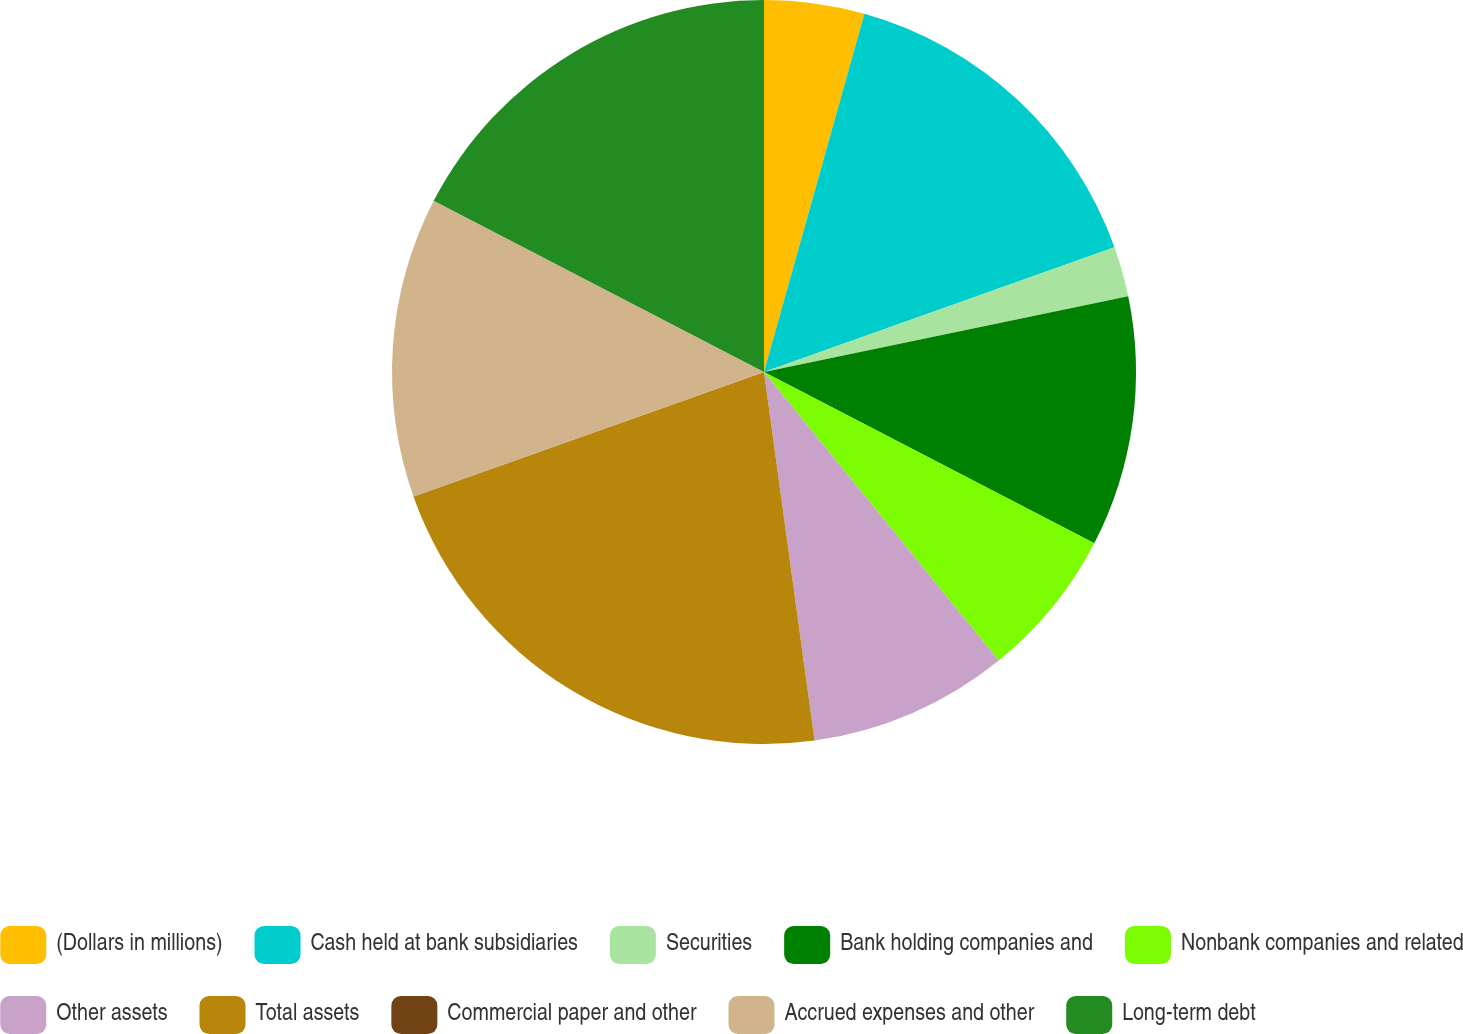<chart> <loc_0><loc_0><loc_500><loc_500><pie_chart><fcel>(Dollars in millions)<fcel>Cash held at bank subsidiaries<fcel>Securities<fcel>Bank holding companies and<fcel>Nonbank companies and related<fcel>Other assets<fcel>Total assets<fcel>Commercial paper and other<fcel>Accrued expenses and other<fcel>Long-term debt<nl><fcel>4.35%<fcel>15.21%<fcel>2.18%<fcel>10.87%<fcel>6.52%<fcel>8.7%<fcel>21.73%<fcel>0.01%<fcel>13.04%<fcel>17.39%<nl></chart> 